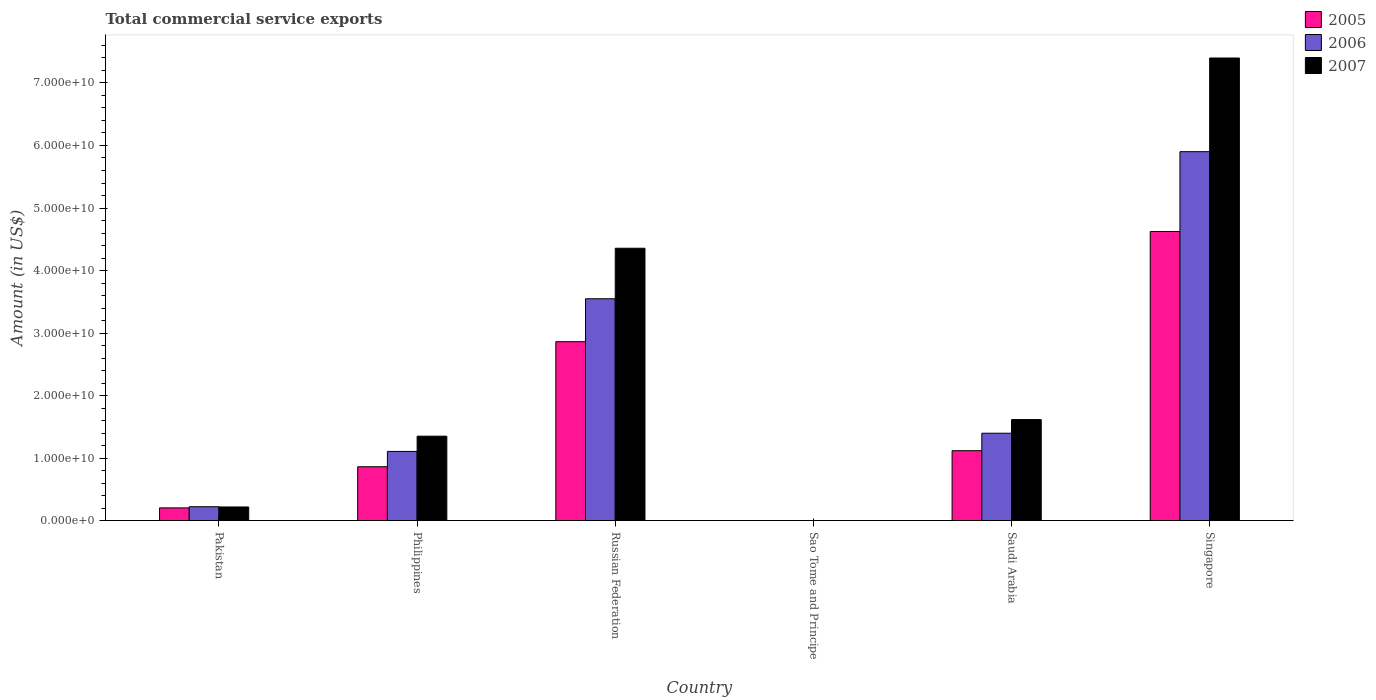How many groups of bars are there?
Offer a very short reply. 6. Are the number of bars per tick equal to the number of legend labels?
Your answer should be compact. Yes. How many bars are there on the 4th tick from the left?
Your answer should be very brief. 3. How many bars are there on the 6th tick from the right?
Keep it short and to the point. 3. In how many cases, is the number of bars for a given country not equal to the number of legend labels?
Your response must be concise. 0. What is the total commercial service exports in 2007 in Pakistan?
Provide a short and direct response. 2.18e+09. Across all countries, what is the maximum total commercial service exports in 2007?
Offer a terse response. 7.40e+1. Across all countries, what is the minimum total commercial service exports in 2007?
Your response must be concise. 6.43e+06. In which country was the total commercial service exports in 2007 maximum?
Your response must be concise. Singapore. In which country was the total commercial service exports in 2005 minimum?
Keep it short and to the point. Sao Tome and Principe. What is the total total commercial service exports in 2006 in the graph?
Offer a terse response. 1.22e+11. What is the difference between the total commercial service exports in 2005 in Sao Tome and Principe and that in Singapore?
Offer a terse response. -4.62e+1. What is the difference between the total commercial service exports in 2007 in Pakistan and the total commercial service exports in 2005 in Singapore?
Your response must be concise. -4.41e+1. What is the average total commercial service exports in 2007 per country?
Provide a short and direct response. 2.49e+1. What is the difference between the total commercial service exports of/in 2005 and total commercial service exports of/in 2006 in Saudi Arabia?
Provide a short and direct response. -2.79e+09. In how many countries, is the total commercial service exports in 2006 greater than 18000000000 US$?
Offer a terse response. 2. What is the ratio of the total commercial service exports in 2007 in Pakistan to that in Russian Federation?
Give a very brief answer. 0.05. Is the difference between the total commercial service exports in 2005 in Russian Federation and Saudi Arabia greater than the difference between the total commercial service exports in 2006 in Russian Federation and Saudi Arabia?
Your answer should be very brief. No. What is the difference between the highest and the second highest total commercial service exports in 2007?
Provide a short and direct response. 2.74e+1. What is the difference between the highest and the lowest total commercial service exports in 2007?
Your answer should be compact. 7.40e+1. What does the 1st bar from the left in Russian Federation represents?
Give a very brief answer. 2005. What does the 2nd bar from the right in Russian Federation represents?
Your answer should be very brief. 2006. Is it the case that in every country, the sum of the total commercial service exports in 2005 and total commercial service exports in 2006 is greater than the total commercial service exports in 2007?
Keep it short and to the point. Yes. Are all the bars in the graph horizontal?
Keep it short and to the point. No. What is the difference between two consecutive major ticks on the Y-axis?
Offer a very short reply. 1.00e+1. Are the values on the major ticks of Y-axis written in scientific E-notation?
Provide a short and direct response. Yes. How many legend labels are there?
Your answer should be very brief. 3. What is the title of the graph?
Ensure brevity in your answer.  Total commercial service exports. What is the label or title of the X-axis?
Offer a very short reply. Country. What is the Amount (in US$) of 2005 in Pakistan?
Provide a short and direct response. 2.03e+09. What is the Amount (in US$) of 2006 in Pakistan?
Give a very brief answer. 2.22e+09. What is the Amount (in US$) of 2007 in Pakistan?
Give a very brief answer. 2.18e+09. What is the Amount (in US$) in 2005 in Philippines?
Offer a terse response. 8.61e+09. What is the Amount (in US$) in 2006 in Philippines?
Your answer should be very brief. 1.11e+1. What is the Amount (in US$) of 2007 in Philippines?
Keep it short and to the point. 1.35e+1. What is the Amount (in US$) in 2005 in Russian Federation?
Your response must be concise. 2.86e+1. What is the Amount (in US$) of 2006 in Russian Federation?
Keep it short and to the point. 3.55e+1. What is the Amount (in US$) of 2007 in Russian Federation?
Provide a short and direct response. 4.36e+1. What is the Amount (in US$) of 2005 in Sao Tome and Principe?
Give a very brief answer. 8.86e+06. What is the Amount (in US$) of 2006 in Sao Tome and Principe?
Your response must be concise. 8.14e+06. What is the Amount (in US$) of 2007 in Sao Tome and Principe?
Provide a short and direct response. 6.43e+06. What is the Amount (in US$) in 2005 in Saudi Arabia?
Offer a very short reply. 1.12e+1. What is the Amount (in US$) of 2006 in Saudi Arabia?
Give a very brief answer. 1.40e+1. What is the Amount (in US$) in 2007 in Saudi Arabia?
Your answer should be very brief. 1.62e+1. What is the Amount (in US$) in 2005 in Singapore?
Ensure brevity in your answer.  4.62e+1. What is the Amount (in US$) in 2006 in Singapore?
Offer a very short reply. 5.90e+1. What is the Amount (in US$) in 2007 in Singapore?
Your answer should be very brief. 7.40e+1. Across all countries, what is the maximum Amount (in US$) in 2005?
Your answer should be very brief. 4.62e+1. Across all countries, what is the maximum Amount (in US$) in 2006?
Your answer should be very brief. 5.90e+1. Across all countries, what is the maximum Amount (in US$) in 2007?
Give a very brief answer. 7.40e+1. Across all countries, what is the minimum Amount (in US$) in 2005?
Your answer should be very brief. 8.86e+06. Across all countries, what is the minimum Amount (in US$) of 2006?
Give a very brief answer. 8.14e+06. Across all countries, what is the minimum Amount (in US$) of 2007?
Offer a terse response. 6.43e+06. What is the total Amount (in US$) in 2005 in the graph?
Your response must be concise. 9.67e+1. What is the total Amount (in US$) of 2006 in the graph?
Provide a succinct answer. 1.22e+11. What is the total Amount (in US$) in 2007 in the graph?
Your answer should be compact. 1.49e+11. What is the difference between the Amount (in US$) of 2005 in Pakistan and that in Philippines?
Ensure brevity in your answer.  -6.58e+09. What is the difference between the Amount (in US$) in 2006 in Pakistan and that in Philippines?
Make the answer very short. -8.85e+09. What is the difference between the Amount (in US$) in 2007 in Pakistan and that in Philippines?
Ensure brevity in your answer.  -1.13e+1. What is the difference between the Amount (in US$) in 2005 in Pakistan and that in Russian Federation?
Make the answer very short. -2.66e+1. What is the difference between the Amount (in US$) in 2006 in Pakistan and that in Russian Federation?
Your answer should be very brief. -3.33e+1. What is the difference between the Amount (in US$) of 2007 in Pakistan and that in Russian Federation?
Offer a terse response. -4.14e+1. What is the difference between the Amount (in US$) of 2005 in Pakistan and that in Sao Tome and Principe?
Ensure brevity in your answer.  2.02e+09. What is the difference between the Amount (in US$) in 2006 in Pakistan and that in Sao Tome and Principe?
Offer a very short reply. 2.21e+09. What is the difference between the Amount (in US$) of 2007 in Pakistan and that in Sao Tome and Principe?
Keep it short and to the point. 2.17e+09. What is the difference between the Amount (in US$) of 2005 in Pakistan and that in Saudi Arabia?
Your response must be concise. -9.15e+09. What is the difference between the Amount (in US$) in 2006 in Pakistan and that in Saudi Arabia?
Your answer should be compact. -1.18e+1. What is the difference between the Amount (in US$) of 2007 in Pakistan and that in Saudi Arabia?
Make the answer very short. -1.40e+1. What is the difference between the Amount (in US$) of 2005 in Pakistan and that in Singapore?
Provide a succinct answer. -4.42e+1. What is the difference between the Amount (in US$) in 2006 in Pakistan and that in Singapore?
Keep it short and to the point. -5.68e+1. What is the difference between the Amount (in US$) in 2007 in Pakistan and that in Singapore?
Provide a short and direct response. -7.18e+1. What is the difference between the Amount (in US$) of 2005 in Philippines and that in Russian Federation?
Keep it short and to the point. -2.00e+1. What is the difference between the Amount (in US$) of 2006 in Philippines and that in Russian Federation?
Offer a terse response. -2.44e+1. What is the difference between the Amount (in US$) of 2007 in Philippines and that in Russian Federation?
Offer a very short reply. -3.01e+1. What is the difference between the Amount (in US$) in 2005 in Philippines and that in Sao Tome and Principe?
Your answer should be very brief. 8.60e+09. What is the difference between the Amount (in US$) of 2006 in Philippines and that in Sao Tome and Principe?
Make the answer very short. 1.11e+1. What is the difference between the Amount (in US$) of 2007 in Philippines and that in Sao Tome and Principe?
Keep it short and to the point. 1.35e+1. What is the difference between the Amount (in US$) in 2005 in Philippines and that in Saudi Arabia?
Offer a terse response. -2.57e+09. What is the difference between the Amount (in US$) of 2006 in Philippines and that in Saudi Arabia?
Your response must be concise. -2.91e+09. What is the difference between the Amount (in US$) of 2007 in Philippines and that in Saudi Arabia?
Offer a terse response. -2.66e+09. What is the difference between the Amount (in US$) in 2005 in Philippines and that in Singapore?
Your answer should be very brief. -3.76e+1. What is the difference between the Amount (in US$) in 2006 in Philippines and that in Singapore?
Your answer should be very brief. -4.79e+1. What is the difference between the Amount (in US$) in 2007 in Philippines and that in Singapore?
Offer a very short reply. -6.05e+1. What is the difference between the Amount (in US$) of 2005 in Russian Federation and that in Sao Tome and Principe?
Make the answer very short. 2.86e+1. What is the difference between the Amount (in US$) of 2006 in Russian Federation and that in Sao Tome and Principe?
Give a very brief answer. 3.55e+1. What is the difference between the Amount (in US$) in 2007 in Russian Federation and that in Sao Tome and Principe?
Ensure brevity in your answer.  4.36e+1. What is the difference between the Amount (in US$) in 2005 in Russian Federation and that in Saudi Arabia?
Ensure brevity in your answer.  1.74e+1. What is the difference between the Amount (in US$) of 2006 in Russian Federation and that in Saudi Arabia?
Your answer should be compact. 2.15e+1. What is the difference between the Amount (in US$) of 2007 in Russian Federation and that in Saudi Arabia?
Your response must be concise. 2.74e+1. What is the difference between the Amount (in US$) in 2005 in Russian Federation and that in Singapore?
Your response must be concise. -1.76e+1. What is the difference between the Amount (in US$) in 2006 in Russian Federation and that in Singapore?
Offer a very short reply. -2.35e+1. What is the difference between the Amount (in US$) of 2007 in Russian Federation and that in Singapore?
Your response must be concise. -3.04e+1. What is the difference between the Amount (in US$) of 2005 in Sao Tome and Principe and that in Saudi Arabia?
Your response must be concise. -1.12e+1. What is the difference between the Amount (in US$) of 2006 in Sao Tome and Principe and that in Saudi Arabia?
Provide a short and direct response. -1.40e+1. What is the difference between the Amount (in US$) in 2007 in Sao Tome and Principe and that in Saudi Arabia?
Offer a terse response. -1.62e+1. What is the difference between the Amount (in US$) in 2005 in Sao Tome and Principe and that in Singapore?
Make the answer very short. -4.62e+1. What is the difference between the Amount (in US$) in 2006 in Sao Tome and Principe and that in Singapore?
Give a very brief answer. -5.90e+1. What is the difference between the Amount (in US$) of 2007 in Sao Tome and Principe and that in Singapore?
Make the answer very short. -7.40e+1. What is the difference between the Amount (in US$) in 2005 in Saudi Arabia and that in Singapore?
Offer a very short reply. -3.51e+1. What is the difference between the Amount (in US$) in 2006 in Saudi Arabia and that in Singapore?
Your answer should be very brief. -4.50e+1. What is the difference between the Amount (in US$) in 2007 in Saudi Arabia and that in Singapore?
Give a very brief answer. -5.78e+1. What is the difference between the Amount (in US$) in 2005 in Pakistan and the Amount (in US$) in 2006 in Philippines?
Your answer should be very brief. -9.03e+09. What is the difference between the Amount (in US$) in 2005 in Pakistan and the Amount (in US$) in 2007 in Philippines?
Your answer should be very brief. -1.15e+1. What is the difference between the Amount (in US$) of 2006 in Pakistan and the Amount (in US$) of 2007 in Philippines?
Keep it short and to the point. -1.13e+1. What is the difference between the Amount (in US$) of 2005 in Pakistan and the Amount (in US$) of 2006 in Russian Federation?
Make the answer very short. -3.35e+1. What is the difference between the Amount (in US$) of 2005 in Pakistan and the Amount (in US$) of 2007 in Russian Federation?
Ensure brevity in your answer.  -4.15e+1. What is the difference between the Amount (in US$) of 2006 in Pakistan and the Amount (in US$) of 2007 in Russian Federation?
Ensure brevity in your answer.  -4.13e+1. What is the difference between the Amount (in US$) of 2005 in Pakistan and the Amount (in US$) of 2006 in Sao Tome and Principe?
Ensure brevity in your answer.  2.02e+09. What is the difference between the Amount (in US$) of 2005 in Pakistan and the Amount (in US$) of 2007 in Sao Tome and Principe?
Offer a terse response. 2.02e+09. What is the difference between the Amount (in US$) of 2006 in Pakistan and the Amount (in US$) of 2007 in Sao Tome and Principe?
Provide a short and direct response. 2.21e+09. What is the difference between the Amount (in US$) in 2005 in Pakistan and the Amount (in US$) in 2006 in Saudi Arabia?
Provide a succinct answer. -1.19e+1. What is the difference between the Amount (in US$) in 2005 in Pakistan and the Amount (in US$) in 2007 in Saudi Arabia?
Offer a terse response. -1.41e+1. What is the difference between the Amount (in US$) of 2006 in Pakistan and the Amount (in US$) of 2007 in Saudi Arabia?
Provide a short and direct response. -1.39e+1. What is the difference between the Amount (in US$) in 2005 in Pakistan and the Amount (in US$) in 2006 in Singapore?
Ensure brevity in your answer.  -5.70e+1. What is the difference between the Amount (in US$) in 2005 in Pakistan and the Amount (in US$) in 2007 in Singapore?
Offer a terse response. -7.20e+1. What is the difference between the Amount (in US$) in 2006 in Pakistan and the Amount (in US$) in 2007 in Singapore?
Your answer should be compact. -7.18e+1. What is the difference between the Amount (in US$) of 2005 in Philippines and the Amount (in US$) of 2006 in Russian Federation?
Provide a succinct answer. -2.69e+1. What is the difference between the Amount (in US$) in 2005 in Philippines and the Amount (in US$) in 2007 in Russian Federation?
Make the answer very short. -3.50e+1. What is the difference between the Amount (in US$) in 2006 in Philippines and the Amount (in US$) in 2007 in Russian Federation?
Provide a short and direct response. -3.25e+1. What is the difference between the Amount (in US$) of 2005 in Philippines and the Amount (in US$) of 2006 in Sao Tome and Principe?
Give a very brief answer. 8.60e+09. What is the difference between the Amount (in US$) of 2005 in Philippines and the Amount (in US$) of 2007 in Sao Tome and Principe?
Keep it short and to the point. 8.60e+09. What is the difference between the Amount (in US$) in 2006 in Philippines and the Amount (in US$) in 2007 in Sao Tome and Principe?
Your answer should be compact. 1.11e+1. What is the difference between the Amount (in US$) in 2005 in Philippines and the Amount (in US$) in 2006 in Saudi Arabia?
Provide a short and direct response. -5.36e+09. What is the difference between the Amount (in US$) in 2005 in Philippines and the Amount (in US$) in 2007 in Saudi Arabia?
Offer a terse response. -7.55e+09. What is the difference between the Amount (in US$) of 2006 in Philippines and the Amount (in US$) of 2007 in Saudi Arabia?
Offer a very short reply. -5.10e+09. What is the difference between the Amount (in US$) of 2005 in Philippines and the Amount (in US$) of 2006 in Singapore?
Make the answer very short. -5.04e+1. What is the difference between the Amount (in US$) in 2005 in Philippines and the Amount (in US$) in 2007 in Singapore?
Keep it short and to the point. -6.54e+1. What is the difference between the Amount (in US$) in 2006 in Philippines and the Amount (in US$) in 2007 in Singapore?
Offer a very short reply. -6.29e+1. What is the difference between the Amount (in US$) of 2005 in Russian Federation and the Amount (in US$) of 2006 in Sao Tome and Principe?
Make the answer very short. 2.86e+1. What is the difference between the Amount (in US$) of 2005 in Russian Federation and the Amount (in US$) of 2007 in Sao Tome and Principe?
Make the answer very short. 2.86e+1. What is the difference between the Amount (in US$) of 2006 in Russian Federation and the Amount (in US$) of 2007 in Sao Tome and Principe?
Offer a terse response. 3.55e+1. What is the difference between the Amount (in US$) of 2005 in Russian Federation and the Amount (in US$) of 2006 in Saudi Arabia?
Your answer should be very brief. 1.46e+1. What is the difference between the Amount (in US$) of 2005 in Russian Federation and the Amount (in US$) of 2007 in Saudi Arabia?
Provide a short and direct response. 1.25e+1. What is the difference between the Amount (in US$) of 2006 in Russian Federation and the Amount (in US$) of 2007 in Saudi Arabia?
Offer a terse response. 1.93e+1. What is the difference between the Amount (in US$) of 2005 in Russian Federation and the Amount (in US$) of 2006 in Singapore?
Give a very brief answer. -3.04e+1. What is the difference between the Amount (in US$) in 2005 in Russian Federation and the Amount (in US$) in 2007 in Singapore?
Offer a terse response. -4.54e+1. What is the difference between the Amount (in US$) of 2006 in Russian Federation and the Amount (in US$) of 2007 in Singapore?
Provide a succinct answer. -3.85e+1. What is the difference between the Amount (in US$) in 2005 in Sao Tome and Principe and the Amount (in US$) in 2006 in Saudi Arabia?
Provide a short and direct response. -1.40e+1. What is the difference between the Amount (in US$) in 2005 in Sao Tome and Principe and the Amount (in US$) in 2007 in Saudi Arabia?
Offer a terse response. -1.62e+1. What is the difference between the Amount (in US$) in 2006 in Sao Tome and Principe and the Amount (in US$) in 2007 in Saudi Arabia?
Your response must be concise. -1.62e+1. What is the difference between the Amount (in US$) in 2005 in Sao Tome and Principe and the Amount (in US$) in 2006 in Singapore?
Offer a very short reply. -5.90e+1. What is the difference between the Amount (in US$) of 2005 in Sao Tome and Principe and the Amount (in US$) of 2007 in Singapore?
Offer a terse response. -7.40e+1. What is the difference between the Amount (in US$) in 2006 in Sao Tome and Principe and the Amount (in US$) in 2007 in Singapore?
Make the answer very short. -7.40e+1. What is the difference between the Amount (in US$) of 2005 in Saudi Arabia and the Amount (in US$) of 2006 in Singapore?
Your answer should be compact. -4.78e+1. What is the difference between the Amount (in US$) in 2005 in Saudi Arabia and the Amount (in US$) in 2007 in Singapore?
Give a very brief answer. -6.28e+1. What is the difference between the Amount (in US$) in 2006 in Saudi Arabia and the Amount (in US$) in 2007 in Singapore?
Keep it short and to the point. -6.00e+1. What is the average Amount (in US$) in 2005 per country?
Your answer should be compact. 1.61e+1. What is the average Amount (in US$) in 2006 per country?
Ensure brevity in your answer.  2.03e+1. What is the average Amount (in US$) of 2007 per country?
Your response must be concise. 2.49e+1. What is the difference between the Amount (in US$) in 2005 and Amount (in US$) in 2006 in Pakistan?
Your answer should be very brief. -1.85e+08. What is the difference between the Amount (in US$) in 2005 and Amount (in US$) in 2007 in Pakistan?
Your answer should be compact. -1.48e+08. What is the difference between the Amount (in US$) of 2006 and Amount (in US$) of 2007 in Pakistan?
Your response must be concise. 3.73e+07. What is the difference between the Amount (in US$) in 2005 and Amount (in US$) in 2006 in Philippines?
Give a very brief answer. -2.45e+09. What is the difference between the Amount (in US$) of 2005 and Amount (in US$) of 2007 in Philippines?
Your response must be concise. -4.89e+09. What is the difference between the Amount (in US$) of 2006 and Amount (in US$) of 2007 in Philippines?
Provide a succinct answer. -2.44e+09. What is the difference between the Amount (in US$) in 2005 and Amount (in US$) in 2006 in Russian Federation?
Ensure brevity in your answer.  -6.87e+09. What is the difference between the Amount (in US$) in 2005 and Amount (in US$) in 2007 in Russian Federation?
Provide a short and direct response. -1.49e+1. What is the difference between the Amount (in US$) of 2006 and Amount (in US$) of 2007 in Russian Federation?
Offer a very short reply. -8.08e+09. What is the difference between the Amount (in US$) of 2005 and Amount (in US$) of 2006 in Sao Tome and Principe?
Your answer should be very brief. 7.25e+05. What is the difference between the Amount (in US$) of 2005 and Amount (in US$) of 2007 in Sao Tome and Principe?
Offer a terse response. 2.43e+06. What is the difference between the Amount (in US$) in 2006 and Amount (in US$) in 2007 in Sao Tome and Principe?
Offer a very short reply. 1.71e+06. What is the difference between the Amount (in US$) of 2005 and Amount (in US$) of 2006 in Saudi Arabia?
Offer a very short reply. -2.79e+09. What is the difference between the Amount (in US$) of 2005 and Amount (in US$) of 2007 in Saudi Arabia?
Keep it short and to the point. -4.98e+09. What is the difference between the Amount (in US$) in 2006 and Amount (in US$) in 2007 in Saudi Arabia?
Make the answer very short. -2.19e+09. What is the difference between the Amount (in US$) in 2005 and Amount (in US$) in 2006 in Singapore?
Your answer should be compact. -1.28e+1. What is the difference between the Amount (in US$) of 2005 and Amount (in US$) of 2007 in Singapore?
Your response must be concise. -2.78e+1. What is the difference between the Amount (in US$) in 2006 and Amount (in US$) in 2007 in Singapore?
Your response must be concise. -1.50e+1. What is the ratio of the Amount (in US$) of 2005 in Pakistan to that in Philippines?
Make the answer very short. 0.24. What is the ratio of the Amount (in US$) of 2006 in Pakistan to that in Philippines?
Provide a short and direct response. 0.2. What is the ratio of the Amount (in US$) of 2007 in Pakistan to that in Philippines?
Your answer should be compact. 0.16. What is the ratio of the Amount (in US$) in 2005 in Pakistan to that in Russian Federation?
Give a very brief answer. 0.07. What is the ratio of the Amount (in US$) of 2006 in Pakistan to that in Russian Federation?
Offer a very short reply. 0.06. What is the ratio of the Amount (in US$) in 2005 in Pakistan to that in Sao Tome and Principe?
Your answer should be very brief. 229.11. What is the ratio of the Amount (in US$) of 2006 in Pakistan to that in Sao Tome and Principe?
Offer a terse response. 272.28. What is the ratio of the Amount (in US$) of 2007 in Pakistan to that in Sao Tome and Principe?
Provide a succinct answer. 338.77. What is the ratio of the Amount (in US$) in 2005 in Pakistan to that in Saudi Arabia?
Offer a terse response. 0.18. What is the ratio of the Amount (in US$) of 2006 in Pakistan to that in Saudi Arabia?
Give a very brief answer. 0.16. What is the ratio of the Amount (in US$) of 2007 in Pakistan to that in Saudi Arabia?
Your answer should be very brief. 0.13. What is the ratio of the Amount (in US$) of 2005 in Pakistan to that in Singapore?
Your answer should be very brief. 0.04. What is the ratio of the Amount (in US$) of 2006 in Pakistan to that in Singapore?
Your answer should be very brief. 0.04. What is the ratio of the Amount (in US$) in 2007 in Pakistan to that in Singapore?
Offer a terse response. 0.03. What is the ratio of the Amount (in US$) in 2005 in Philippines to that in Russian Federation?
Your response must be concise. 0.3. What is the ratio of the Amount (in US$) in 2006 in Philippines to that in Russian Federation?
Your answer should be compact. 0.31. What is the ratio of the Amount (in US$) of 2007 in Philippines to that in Russian Federation?
Offer a terse response. 0.31. What is the ratio of the Amount (in US$) of 2005 in Philippines to that in Sao Tome and Principe?
Ensure brevity in your answer.  971.83. What is the ratio of the Amount (in US$) in 2006 in Philippines to that in Sao Tome and Principe?
Offer a very short reply. 1360.07. What is the ratio of the Amount (in US$) of 2007 in Philippines to that in Sao Tome and Principe?
Your response must be concise. 2100.4. What is the ratio of the Amount (in US$) in 2005 in Philippines to that in Saudi Arabia?
Provide a short and direct response. 0.77. What is the ratio of the Amount (in US$) in 2006 in Philippines to that in Saudi Arabia?
Keep it short and to the point. 0.79. What is the ratio of the Amount (in US$) of 2007 in Philippines to that in Saudi Arabia?
Provide a succinct answer. 0.84. What is the ratio of the Amount (in US$) in 2005 in Philippines to that in Singapore?
Give a very brief answer. 0.19. What is the ratio of the Amount (in US$) of 2006 in Philippines to that in Singapore?
Offer a terse response. 0.19. What is the ratio of the Amount (in US$) of 2007 in Philippines to that in Singapore?
Provide a succinct answer. 0.18. What is the ratio of the Amount (in US$) in 2005 in Russian Federation to that in Sao Tome and Principe?
Your answer should be very brief. 3229.6. What is the ratio of the Amount (in US$) of 2006 in Russian Federation to that in Sao Tome and Principe?
Provide a short and direct response. 4361.62. What is the ratio of the Amount (in US$) in 2007 in Russian Federation to that in Sao Tome and Principe?
Offer a very short reply. 6776.89. What is the ratio of the Amount (in US$) in 2005 in Russian Federation to that in Saudi Arabia?
Offer a very short reply. 2.56. What is the ratio of the Amount (in US$) in 2006 in Russian Federation to that in Saudi Arabia?
Your answer should be very brief. 2.54. What is the ratio of the Amount (in US$) of 2007 in Russian Federation to that in Saudi Arabia?
Ensure brevity in your answer.  2.7. What is the ratio of the Amount (in US$) in 2005 in Russian Federation to that in Singapore?
Offer a terse response. 0.62. What is the ratio of the Amount (in US$) of 2006 in Russian Federation to that in Singapore?
Provide a succinct answer. 0.6. What is the ratio of the Amount (in US$) in 2007 in Russian Federation to that in Singapore?
Your answer should be compact. 0.59. What is the ratio of the Amount (in US$) of 2005 in Sao Tome and Principe to that in Saudi Arabia?
Your response must be concise. 0. What is the ratio of the Amount (in US$) of 2006 in Sao Tome and Principe to that in Saudi Arabia?
Keep it short and to the point. 0. What is the ratio of the Amount (in US$) in 2006 in Sao Tome and Principe to that in Singapore?
Your answer should be compact. 0. What is the ratio of the Amount (in US$) of 2005 in Saudi Arabia to that in Singapore?
Offer a very short reply. 0.24. What is the ratio of the Amount (in US$) of 2006 in Saudi Arabia to that in Singapore?
Provide a succinct answer. 0.24. What is the ratio of the Amount (in US$) of 2007 in Saudi Arabia to that in Singapore?
Offer a terse response. 0.22. What is the difference between the highest and the second highest Amount (in US$) of 2005?
Ensure brevity in your answer.  1.76e+1. What is the difference between the highest and the second highest Amount (in US$) in 2006?
Give a very brief answer. 2.35e+1. What is the difference between the highest and the second highest Amount (in US$) of 2007?
Offer a very short reply. 3.04e+1. What is the difference between the highest and the lowest Amount (in US$) of 2005?
Offer a terse response. 4.62e+1. What is the difference between the highest and the lowest Amount (in US$) in 2006?
Keep it short and to the point. 5.90e+1. What is the difference between the highest and the lowest Amount (in US$) in 2007?
Offer a terse response. 7.40e+1. 